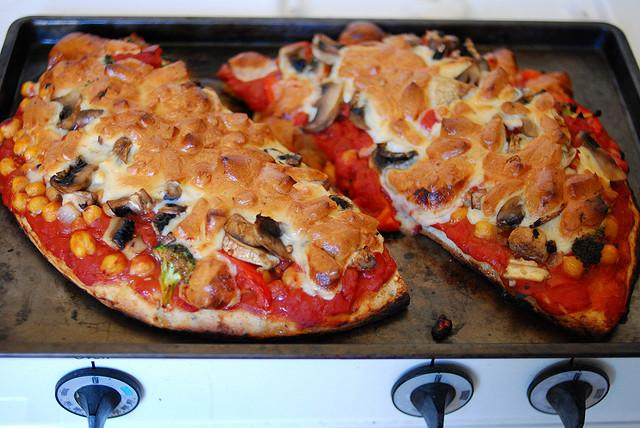What are the round things on the outer edge? Please explain your reasoning. garbanzo beans. The round things are beans. 